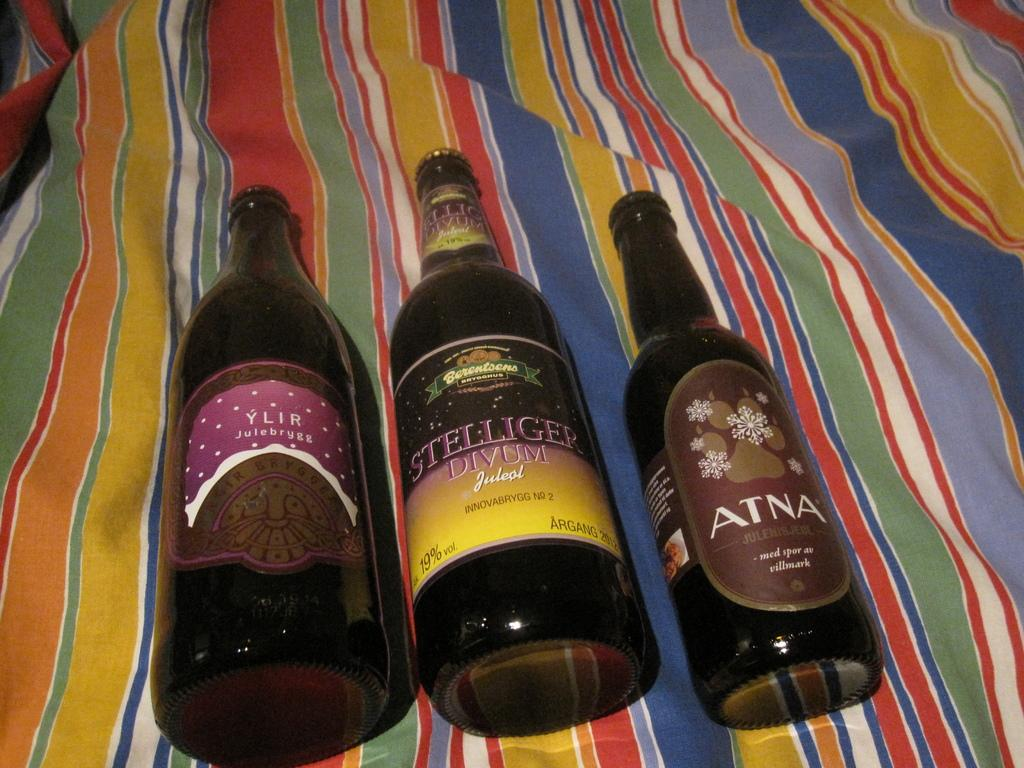<image>
Render a clear and concise summary of the photo. An opened bottle of Atna lies on a colorful cloth with two other bottles. 